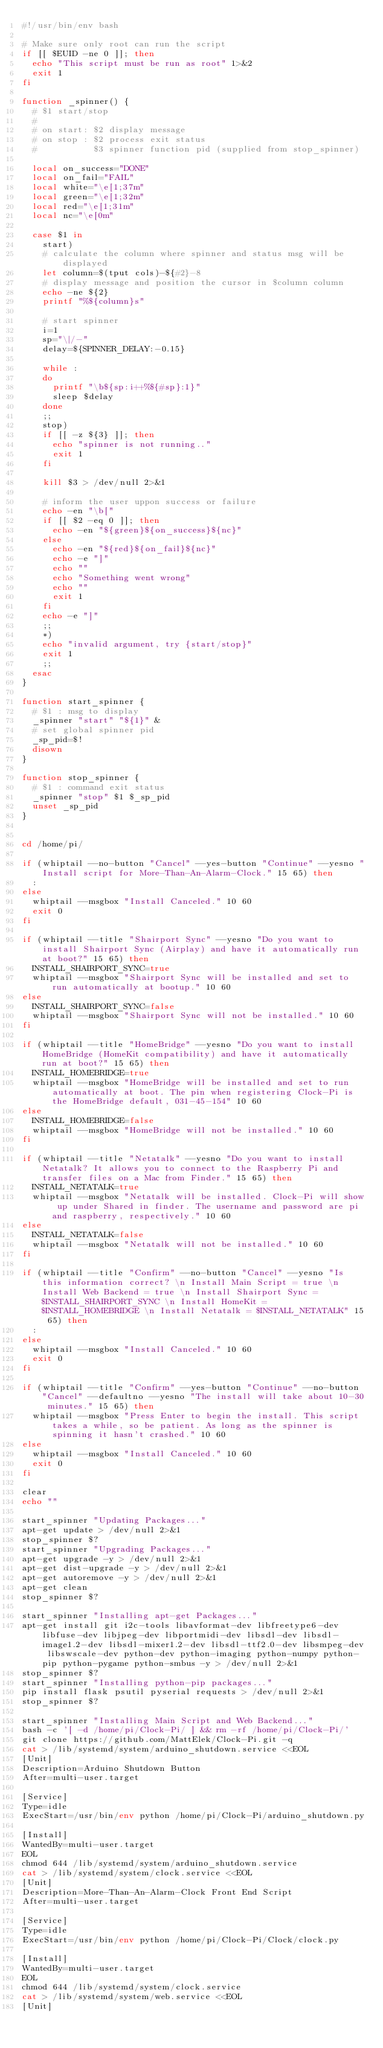Convert code to text. <code><loc_0><loc_0><loc_500><loc_500><_Bash_>#!/usr/bin/env bash

# Make sure only root can run the script
if [[ $EUID -ne 0 ]]; then
  echo "This script must be run as root" 1>&2
  exit 1
fi

function _spinner() {
  # $1 start/stop
  #
  # on start: $2 display message
  # on stop : $2 process exit status
  #           $3 spinner function pid (supplied from stop_spinner)

  local on_success="DONE"
  local on_fail="FAIL"
  local white="\e[1;37m"
  local green="\e[1;32m"
  local red="\e[1;31m"
  local nc="\e[0m"

  case $1 in
    start)
    # calculate the column where spinner and status msg will be displayed
    let column=$(tput cols)-${#2}-8
    # display message and position the cursor in $column column
    echo -ne ${2}
    printf "%${column}s"

    # start spinner
    i=1
    sp="\|/-"
    delay=${SPINNER_DELAY:-0.15}

    while :
    do
      printf "\b${sp:i++%${#sp}:1}"
      sleep $delay
    done
    ;;
    stop)
    if [[ -z ${3} ]]; then
      echo "spinner is not running.."
      exit 1
    fi

    kill $3 > /dev/null 2>&1

    # inform the user uppon success or failure
    echo -en "\b["
    if [[ $2 -eq 0 ]]; then
      echo -en "${green}${on_success}${nc}"
    else
      echo -en "${red}${on_fail}${nc}"
      echo -e "]"
      echo ""
      echo "Something went wrong"
      echo ""
      exit 1
    fi
    echo -e "]"
    ;;
    *)
    echo "invalid argument, try {start/stop}"
    exit 1
    ;;
  esac
}

function start_spinner {
  # $1 : msg to display
  _spinner "start" "${1}" &
  # set global spinner pid
  _sp_pid=$!
  disown
}

function stop_spinner {
  # $1 : command exit status
  _spinner "stop" $1 $_sp_pid
  unset _sp_pid
}


cd /home/pi/

if (whiptail --no-button "Cancel" --yes-button "Continue" --yesno "Install script for More-Than-An-Alarm-Clock." 15 65) then
  :
else
  whiptail --msgbox "Install Canceled." 10 60
  exit 0
fi

if (whiptail --title "Shairport Sync" --yesno "Do you want to install Shairport Sync (Airplay) and have it automatically run at boot?" 15 65) then
  INSTALL_SHAIRPORT_SYNC=true
  whiptail --msgbox "Shairport Sync will be installed and set to run automatically at bootup." 10 60
else
  INSTALL_SHAIRPORT_SYNC=false
  whiptail --msgbox "Shairport Sync will not be installed." 10 60
fi

if (whiptail --title "HomeBridge" --yesno "Do you want to install HomeBridge (HomeKit compatibility) and have it automatically run at boot?" 15 65) then
  INSTALL_HOMEBRIDGE=true
  whiptail --msgbox "HomeBridge will be installed and set to run automatically at boot. The pin when registering Clock-Pi is the HomeBridge default, 031-45-154" 10 60
else
  INSTALL_HOMEBRIDGE=false
  whiptail --msgbox "HomeBridge will not be installed." 10 60
fi

if (whiptail --title "Netatalk" --yesno "Do you want to install Netatalk? It allows you to connect to the Raspberry Pi and transfer files on a Mac from Finder." 15 65) then
  INSTALL_NETATALK=true
  whiptail --msgbox "Netatalk will be installed. Clock-Pi will show up under Shared in finder. The username and password are pi and raspberry, respectively." 10 60
else
  INSTALL_NETATALK=false
  whiptail --msgbox "Netatalk will not be installed." 10 60
fi

if (whiptail --title "Confirm" --no-button "Cancel" --yesno "Is this information correct? \n Install Main Script = true \n Install Web Backend = true \n Install Shairport Sync = $INSTALL_SHAIRPORT_SYNC \n Install HomeKit = $INSTALL_HOMEBRIDGE \n Install Netatalk = $INSTALL_NETATALK" 15 65) then
  :
else
  whiptail --msgbox "Install Canceled." 10 60
  exit 0
fi

if (whiptail --title "Confirm" --yes-button "Continue" --no-button "Cancel" --defaultno --yesno "The install will take about 10-30 minutes." 15 65) then
  whiptail --msgbox "Press Enter to begin the install. This script takes a while, so be patient. As long as the spinner is spinning it hasn't crashed." 10 60
else
  whiptail --msgbox "Install Canceled." 10 60
  exit 0
fi

clear
echo ""

start_spinner "Updating Packages..."
apt-get update > /dev/null 2>&1
stop_spinner $?
start_spinner "Upgrading Packages..."
apt-get upgrade -y > /dev/null 2>&1
apt-get dist-upgrade -y > /dev/null 2>&1
apt-get autoremove -y > /dev/null 2>&1
apt-get clean
stop_spinner $?

start_spinner "Installing apt-get Packages..."
apt-get install git i2c-tools libavformat-dev libfreetype6-dev libfuse-dev libjpeg-dev libportmidi-dev libsdl-dev libsdl-image1.2-dev libsdl-mixer1.2-dev libsdl-ttf2.0-dev libsmpeg-dev libswscale-dev python-dev python-imaging python-numpy python-pip python-pygame python-smbus -y > /dev/null 2>&1
stop_spinner $?
start_spinner "Installing python-pip packages..."
pip install flask psutil pyserial requests > /dev/null 2>&1
stop_spinner $?

start_spinner "Installing Main Script and Web Backend..."
bash -c '[ -d /home/pi/Clock-Pi/ ] && rm -rf /home/pi/Clock-Pi/'
git clone https://github.com/MattElek/Clock-Pi.git -q
cat > /lib/systemd/system/arduino_shutdown.service <<EOL
[Unit]
Description=Arduino Shutdown Button
After=multi-user.target

[Service]
Type=idle
ExecStart=/usr/bin/env python /home/pi/Clock-Pi/arduino_shutdown.py

[Install]
WantedBy=multi-user.target
EOL
chmod 644 /lib/systemd/system/arduino_shutdown.service
cat > /lib/systemd/system/clock.service <<EOL
[Unit]
Description=More-Than-An-Alarm-Clock Front End Script
After=multi-user.target

[Service]
Type=idle
ExecStart=/usr/bin/env python /home/pi/Clock-Pi/Clock/clock.py

[Install]
WantedBy=multi-user.target
EOL
chmod 644 /lib/systemd/system/clock.service
cat > /lib/systemd/system/web.service <<EOL
[Unit]</code> 